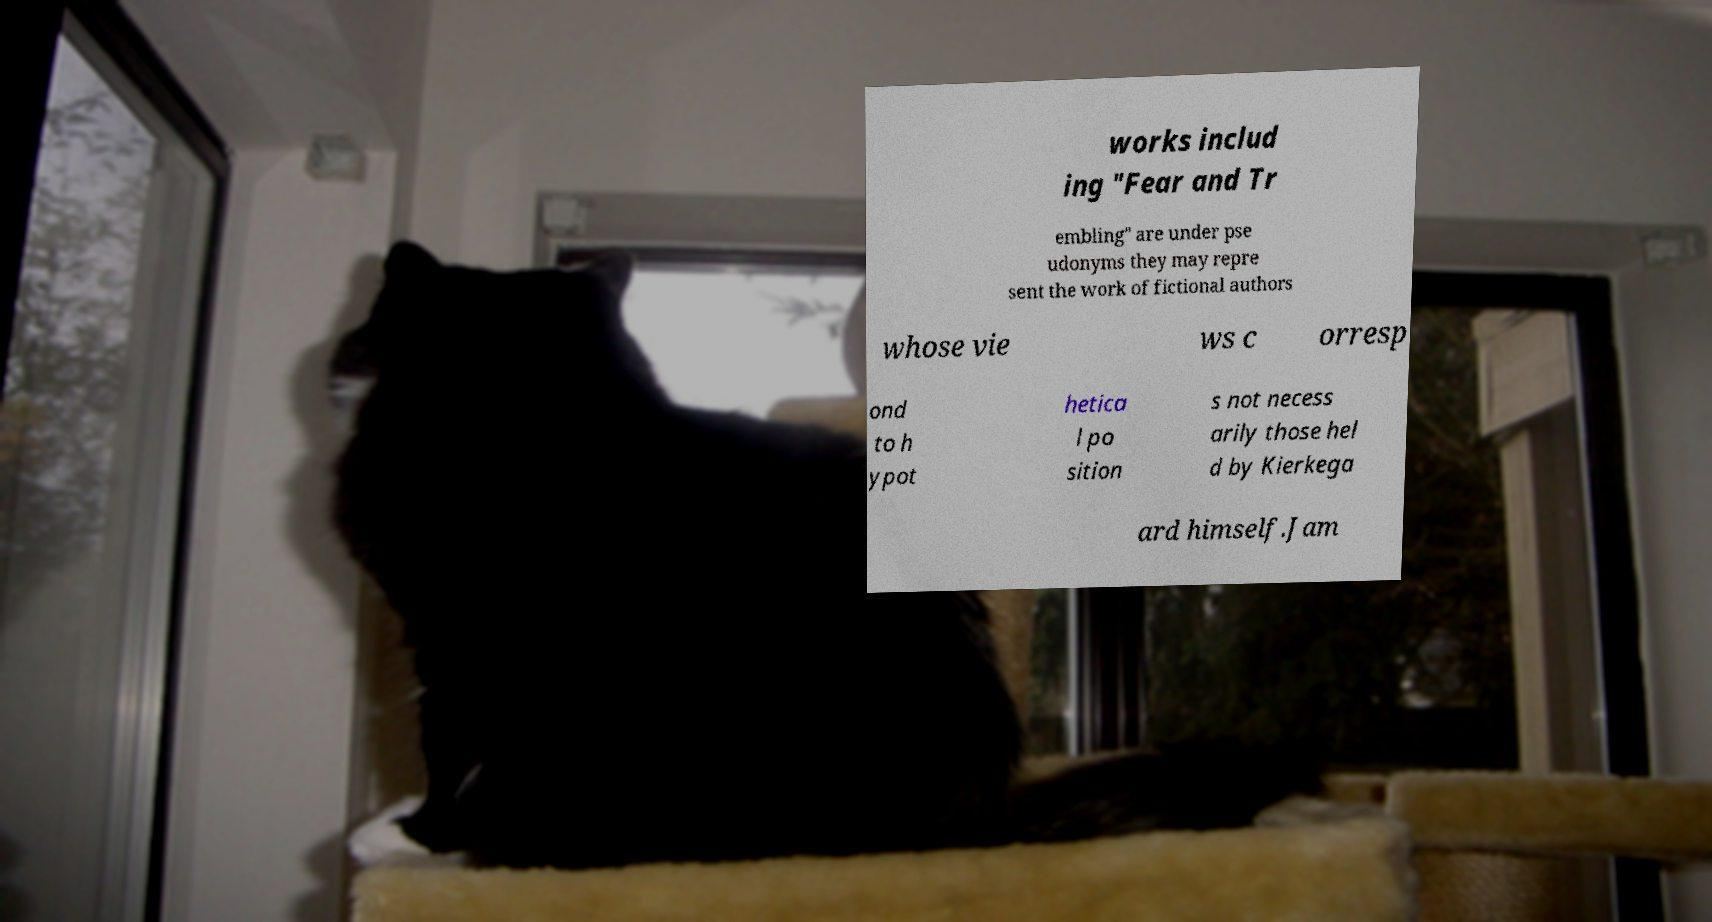Can you read and provide the text displayed in the image?This photo seems to have some interesting text. Can you extract and type it out for me? works includ ing "Fear and Tr embling" are under pse udonyms they may repre sent the work of fictional authors whose vie ws c orresp ond to h ypot hetica l po sition s not necess arily those hel d by Kierkega ard himself.Jam 